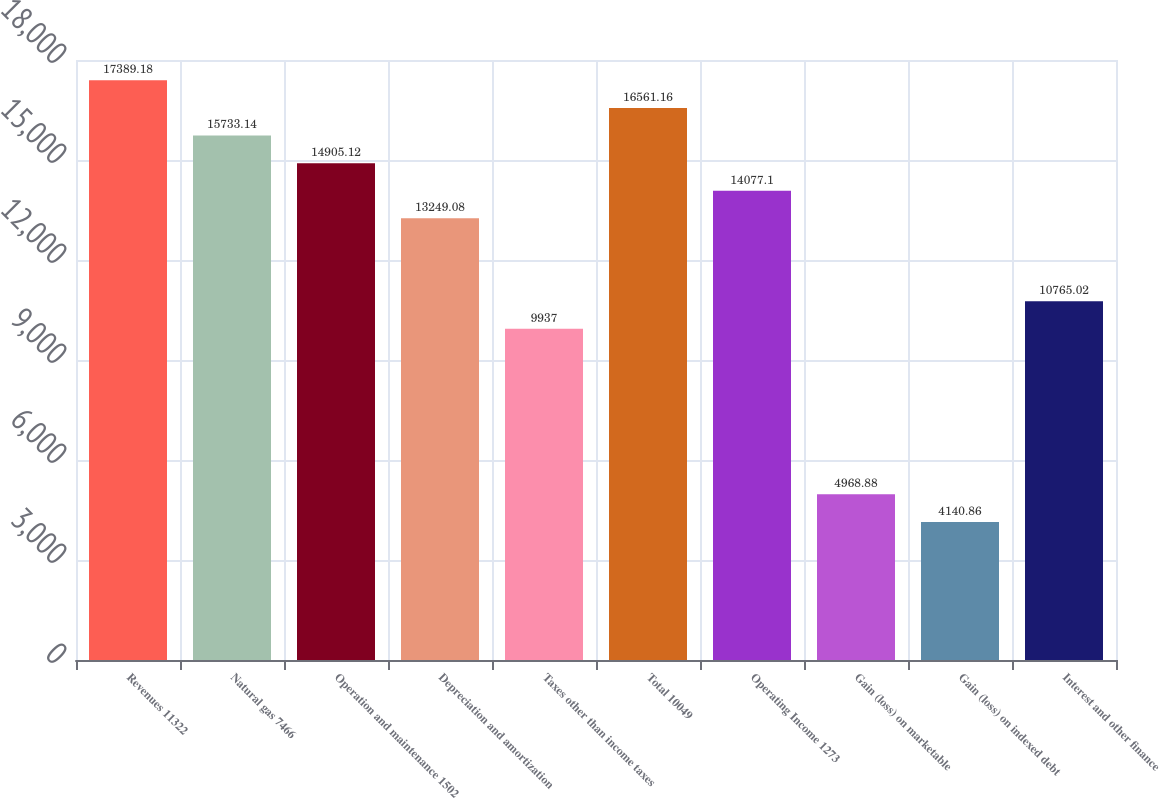Convert chart to OTSL. <chart><loc_0><loc_0><loc_500><loc_500><bar_chart><fcel>Revenues 11322<fcel>Natural gas 7466<fcel>Operation and maintenance 1502<fcel>Depreciation and amortization<fcel>Taxes other than income taxes<fcel>Total 10049<fcel>Operating Income 1273<fcel>Gain (loss) on marketable<fcel>Gain (loss) on indexed debt<fcel>Interest and other finance<nl><fcel>17389.2<fcel>15733.1<fcel>14905.1<fcel>13249.1<fcel>9937<fcel>16561.2<fcel>14077.1<fcel>4968.88<fcel>4140.86<fcel>10765<nl></chart> 